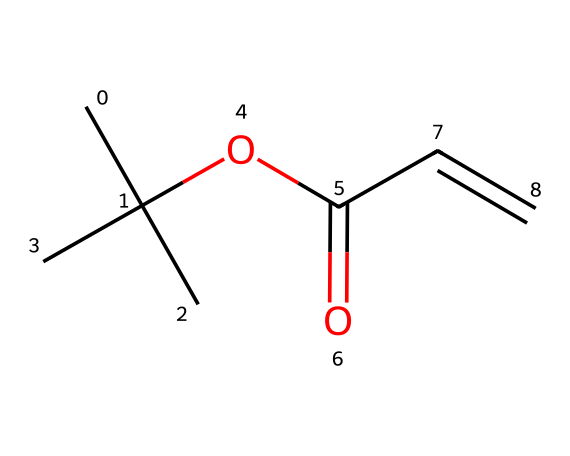What is the molecular formula of this chemical? To determine the molecular formula, we count the number of each type of atom present in the SMILES representation. The structure indicates it contains Carbon (C), Hydrogen (H), and Oxygen (O) atoms. Counting the atoms gives us 6 Carbons, 10 Hydrogens, and 2 Oxygens, leading to the molecular formula C6H10O2.
Answer: C6H10O2 How many rings are present in this chemical structure? By analyzing the SMILES notation, we look for cyclic structures. This SMILES shows a linear structure with no indicators for rings, thus confirming the absence of any cyclic part. Therefore, the count of rings is zero.
Answer: 0 What functional group is present in this compound? Examining the structure reveals that there’s an ester group, characterized by the -OC(=O)- segment of the SMILES representation. This group is typical for photoresists as it facilitates the desired chemical reactions upon exposure to light.
Answer: ester How many double bonds are present in this structure? In the SMILES notation, the presence of double bonds can be identified by the "=" symbol. The structure shows one double bond in the -C=C- segment, making it clear that there is only one double bond in total.
Answer: 1 What type of reaction is this chemical most likely to participate in? Given that this chemical is a photoresist and contains an ester group with a carbon double bond, it is likely to undergo photopolymerization upon exposure to light. This reaction type involves the formation of large polymer chains, essential in semiconductor manufacturing.
Answer: photopolymerization What is the hybridization of the double-bonded carbons in this structure? Analyzing the double bond in the -C=C- segment, we deduce that both carbons related to the double bond have sp2 hybridization. This occurs under the presence of a double bond, which signifies sp2 hybridization for each carbon involved.
Answer: sp2 